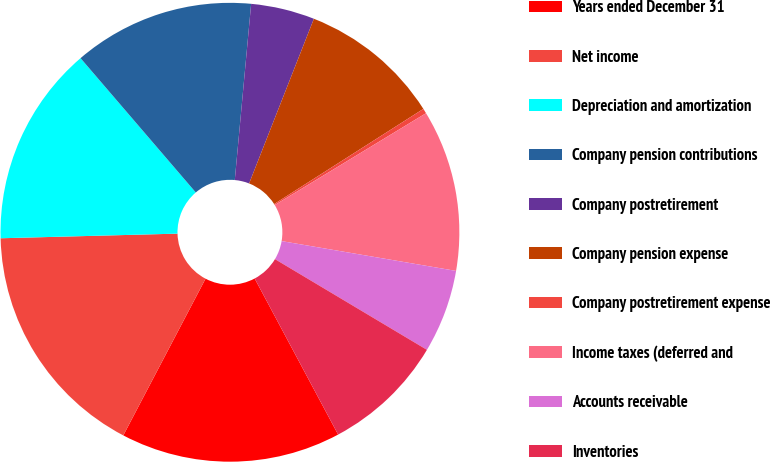Convert chart to OTSL. <chart><loc_0><loc_0><loc_500><loc_500><pie_chart><fcel>Years ended December 31<fcel>Net income<fcel>Depreciation and amortization<fcel>Company pension contributions<fcel>Company postretirement<fcel>Company pension expense<fcel>Company postretirement expense<fcel>Income taxes (deferred and<fcel>Accounts receivable<fcel>Inventories<nl><fcel>15.51%<fcel>16.89%<fcel>14.13%<fcel>12.76%<fcel>4.49%<fcel>10.0%<fcel>0.35%<fcel>11.38%<fcel>5.87%<fcel>8.62%<nl></chart> 